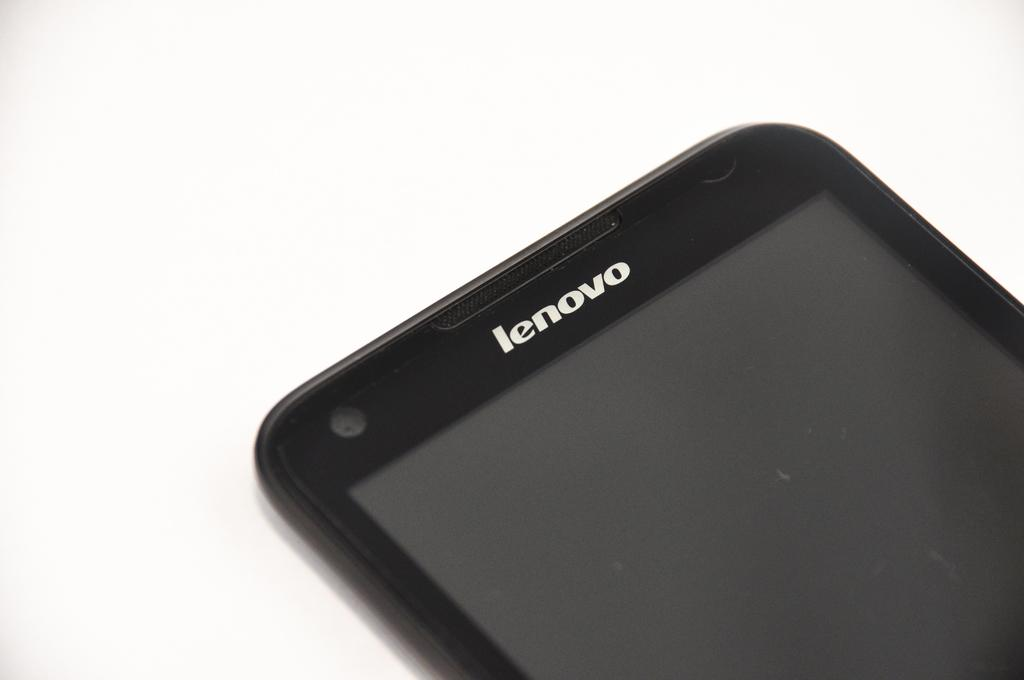<image>
Give a short and clear explanation of the subsequent image. The front of an unpowered lenovo branded cell phone. 